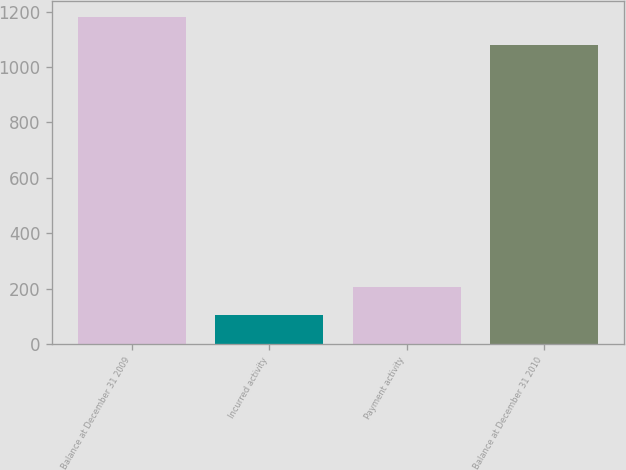<chart> <loc_0><loc_0><loc_500><loc_500><bar_chart><fcel>Balance at December 31 2009<fcel>Incurred activity<fcel>Payment activity<fcel>Balance at December 31 2010<nl><fcel>1180<fcel>103<fcel>205<fcel>1078<nl></chart> 